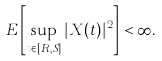Convert formula to latex. <formula><loc_0><loc_0><loc_500><loc_500>E \left [ \sup _ { t \in [ R , S ] } | X ( t ) | ^ { 2 } \right ] < \infty .</formula> 